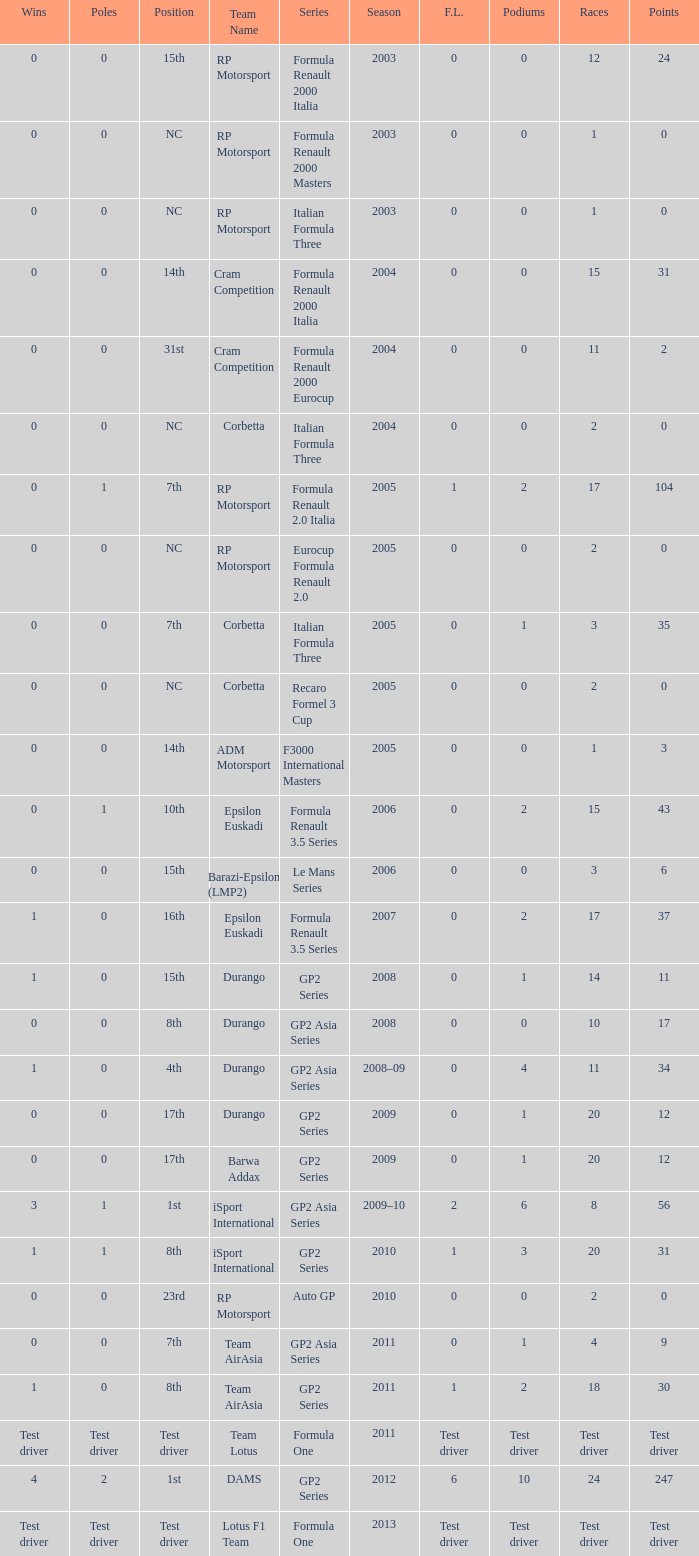Could you parse the entire table? {'header': ['Wins', 'Poles', 'Position', 'Team Name', 'Series', 'Season', 'F.L.', 'Podiums', 'Races', 'Points'], 'rows': [['0', '0', '15th', 'RP Motorsport', 'Formula Renault 2000 Italia', '2003', '0', '0', '12', '24'], ['0', '0', 'NC', 'RP Motorsport', 'Formula Renault 2000 Masters', '2003', '0', '0', '1', '0'], ['0', '0', 'NC', 'RP Motorsport', 'Italian Formula Three', '2003', '0', '0', '1', '0'], ['0', '0', '14th', 'Cram Competition', 'Formula Renault 2000 Italia', '2004', '0', '0', '15', '31'], ['0', '0', '31st', 'Cram Competition', 'Formula Renault 2000 Eurocup', '2004', '0', '0', '11', '2'], ['0', '0', 'NC', 'Corbetta', 'Italian Formula Three', '2004', '0', '0', '2', '0'], ['0', '1', '7th', 'RP Motorsport', 'Formula Renault 2.0 Italia', '2005', '1', '2', '17', '104'], ['0', '0', 'NC', 'RP Motorsport', 'Eurocup Formula Renault 2.0', '2005', '0', '0', '2', '0'], ['0', '0', '7th', 'Corbetta', 'Italian Formula Three', '2005', '0', '1', '3', '35'], ['0', '0', 'NC', 'Corbetta', 'Recaro Formel 3 Cup', '2005', '0', '0', '2', '0'], ['0', '0', '14th', 'ADM Motorsport', 'F3000 International Masters', '2005', '0', '0', '1', '3'], ['0', '1', '10th', 'Epsilon Euskadi', 'Formula Renault 3.5 Series', '2006', '0', '2', '15', '43'], ['0', '0', '15th', 'Barazi-Epsilon (LMP2)', 'Le Mans Series', '2006', '0', '0', '3', '6'], ['1', '0', '16th', 'Epsilon Euskadi', 'Formula Renault 3.5 Series', '2007', '0', '2', '17', '37'], ['1', '0', '15th', 'Durango', 'GP2 Series', '2008', '0', '1', '14', '11'], ['0', '0', '8th', 'Durango', 'GP2 Asia Series', '2008', '0', '0', '10', '17'], ['1', '0', '4th', 'Durango', 'GP2 Asia Series', '2008–09', '0', '4', '11', '34'], ['0', '0', '17th', 'Durango', 'GP2 Series', '2009', '0', '1', '20', '12'], ['0', '0', '17th', 'Barwa Addax', 'GP2 Series', '2009', '0', '1', '20', '12'], ['3', '1', '1st', 'iSport International', 'GP2 Asia Series', '2009–10', '2', '6', '8', '56'], ['1', '1', '8th', 'iSport International', 'GP2 Series', '2010', '1', '3', '20', '31'], ['0', '0', '23rd', 'RP Motorsport', 'Auto GP', '2010', '0', '0', '2', '0'], ['0', '0', '7th', 'Team AirAsia', 'GP2 Asia Series', '2011', '0', '1', '4', '9'], ['1', '0', '8th', 'Team AirAsia', 'GP2 Series', '2011', '1', '2', '18', '30'], ['Test driver', 'Test driver', 'Test driver', 'Team Lotus', 'Formula One', '2011', 'Test driver', 'Test driver', 'Test driver', 'Test driver'], ['4', '2', '1st', 'DAMS', 'GP2 Series', '2012', '6', '10', '24', '247'], ['Test driver', 'Test driver', 'Test driver', 'Lotus F1 Team', 'Formula One', '2013', 'Test driver', 'Test driver', 'Test driver', 'Test driver']]} What is the number of podiums with 0 wins and 6 points? 0.0. 